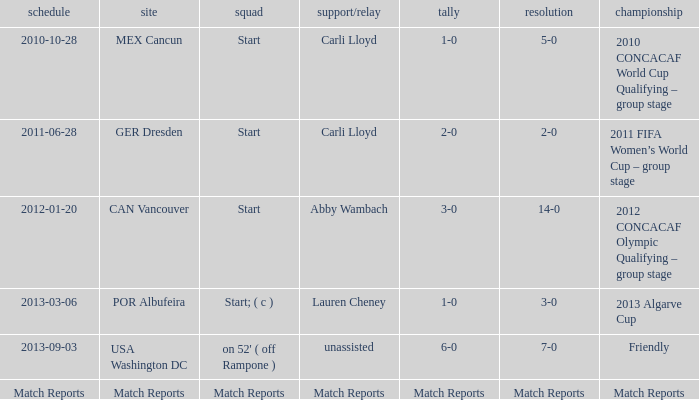Which score has a location of mex cancun? 1-0. 